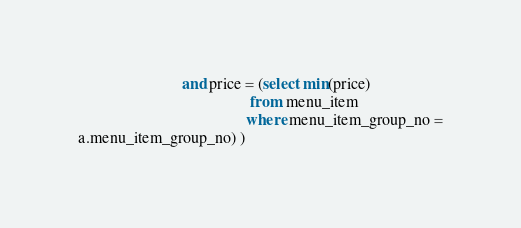Convert code to text. <code><loc_0><loc_0><loc_500><loc_500><_SQL_>                          and price = (select min(price)
                                           from menu_item
                                          where menu_item_group_no =
a.menu_item_group_no) ) </code> 